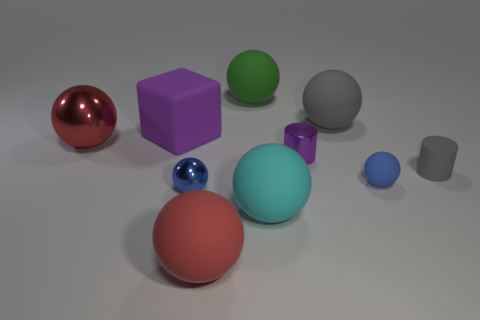Are there any patterns or repetitions in this image? There's a repetition in the objects' shapes. We have two spheres, two cubes, and two cylinders. They are arranged in no discernible pattern but the duplication in shapes brings a sense of balance to the composition. 